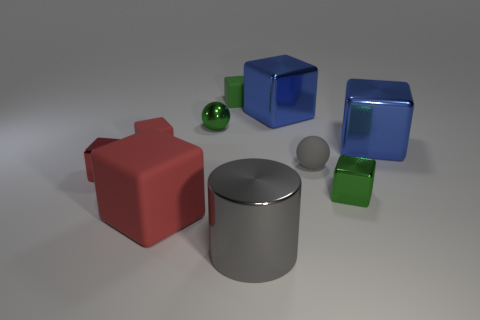The tiny metallic sphere has what color?
Your response must be concise. Green. There is a big thing that is left of the large gray cylinder; does it have the same color as the metal cylinder?
Provide a short and direct response. No. There is a ball that is the same color as the big cylinder; what material is it?
Keep it short and to the point. Rubber. How many rubber cylinders have the same color as the metallic ball?
Provide a short and direct response. 0. There is a matte block that is the same color as the small metallic sphere; what is its size?
Make the answer very short. Small. Is there a blue metallic thing on the left side of the large blue shiny block that is behind the metal sphere?
Your answer should be very brief. No. How many objects are small cubes on the right side of the big gray metallic thing or cubes in front of the gray rubber object?
Keep it short and to the point. 3. Is there anything else of the same color as the large cylinder?
Give a very brief answer. Yes. There is a tiny metallic block that is left of the tiny green thing on the left side of the small object behind the green shiny ball; what color is it?
Your response must be concise. Red. There is a green block that is in front of the red rubber thing left of the large rubber object; what size is it?
Offer a very short reply. Small. 